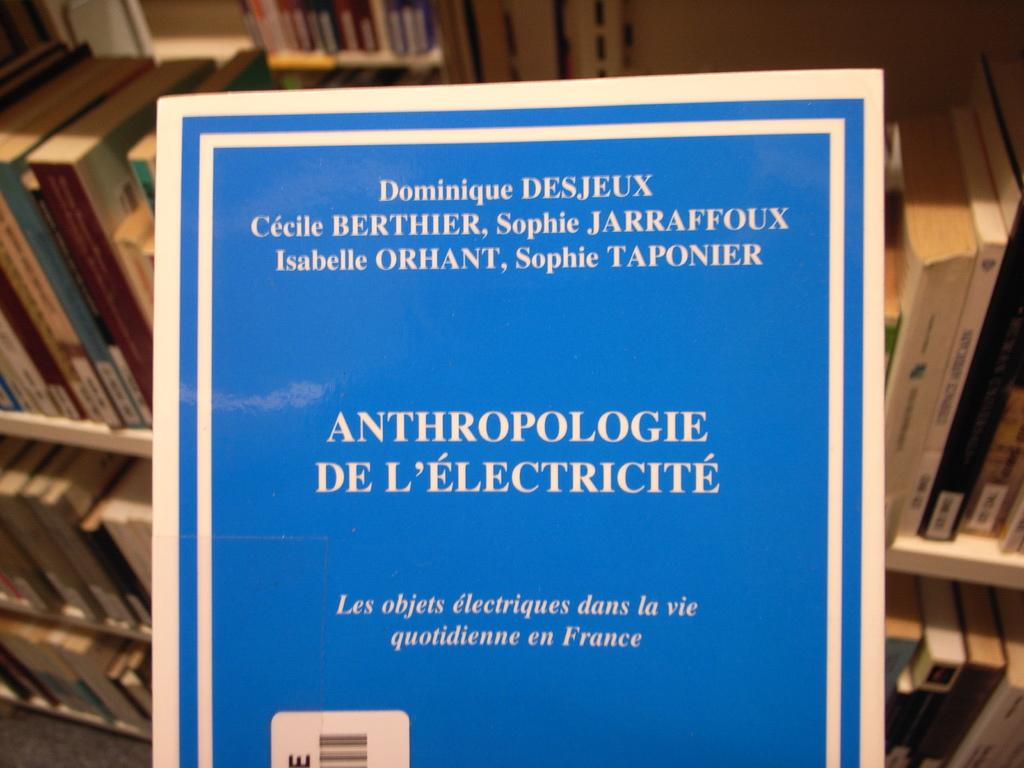<image>
Present a compact description of the photo's key features. A book titled Anthropologie de l'électricité with blue cover. 